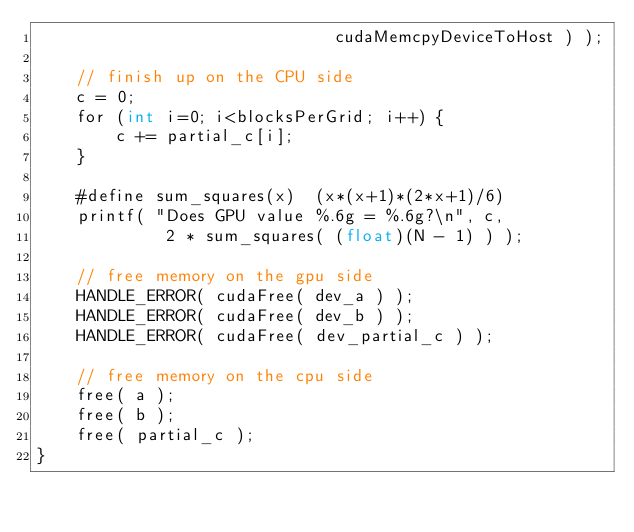<code> <loc_0><loc_0><loc_500><loc_500><_Cuda_>                              cudaMemcpyDeviceToHost ) );

    // finish up on the CPU side
    c = 0;
    for (int i=0; i<blocksPerGrid; i++) {
        c += partial_c[i];
    }

    #define sum_squares(x)  (x*(x+1)*(2*x+1)/6)
    printf( "Does GPU value %.6g = %.6g?\n", c,
             2 * sum_squares( (float)(N - 1) ) );

    // free memory on the gpu side
    HANDLE_ERROR( cudaFree( dev_a ) );
    HANDLE_ERROR( cudaFree( dev_b ) );
    HANDLE_ERROR( cudaFree( dev_partial_c ) );

    // free memory on the cpu side
    free( a );
    free( b );
    free( partial_c );
}
</code> 